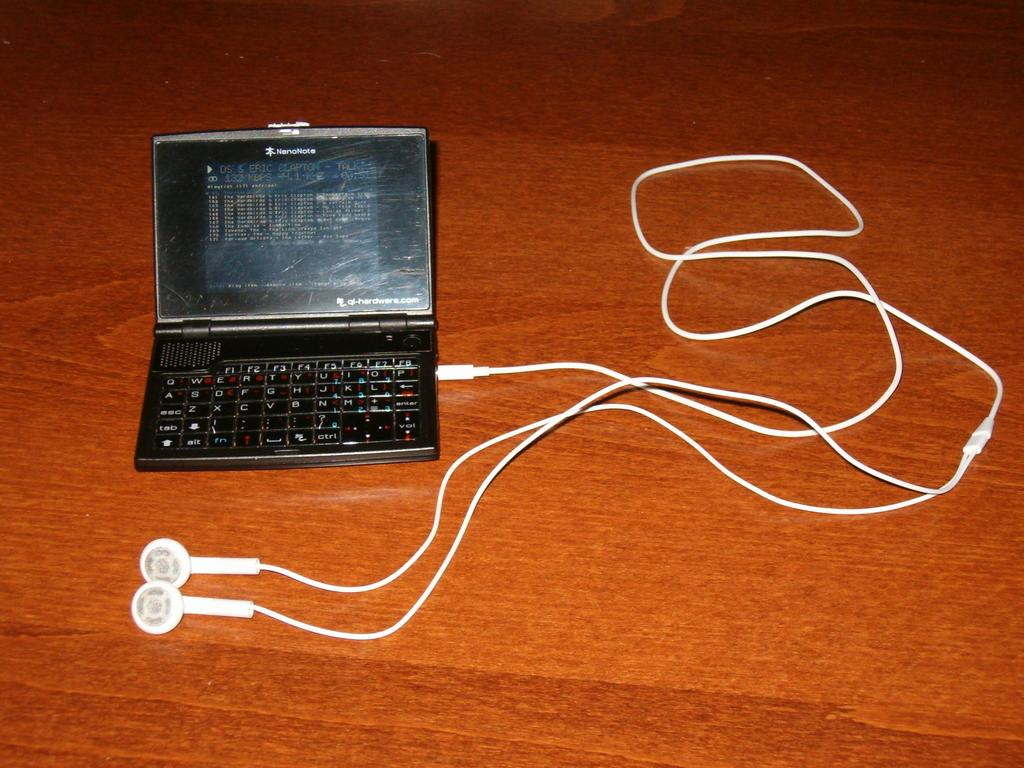What is the main object in the image? There is a mini top in the image. What is connected to the mini top? Earphones are plugged into the mini top. What letters can be seen on the mini top in the image? There is no information about letters on the mini top in the provided facts, so we cannot determine if any letters are visible. 